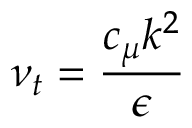Convert formula to latex. <formula><loc_0><loc_0><loc_500><loc_500>\nu _ { t } = { \frac { c _ { \mu } k ^ { 2 } } { \epsilon } }</formula> 